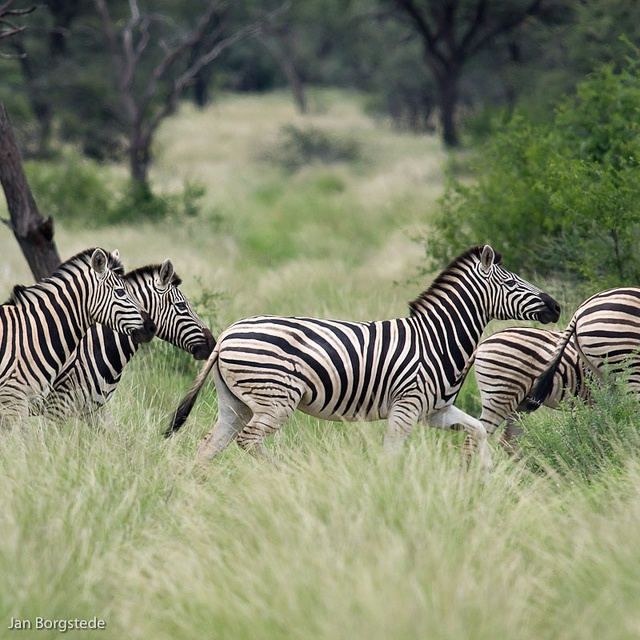Describe the objects in this image and their specific colors. I can see zebra in black, darkgray, lightgray, and gray tones, zebra in black, darkgray, lightgray, and gray tones, zebra in black, darkgray, gray, and lightgray tones, zebra in black, gray, darkgray, and lightgray tones, and zebra in black, gray, lightgray, and darkgray tones in this image. 